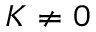Convert formula to latex. <formula><loc_0><loc_0><loc_500><loc_500>K \neq 0</formula> 